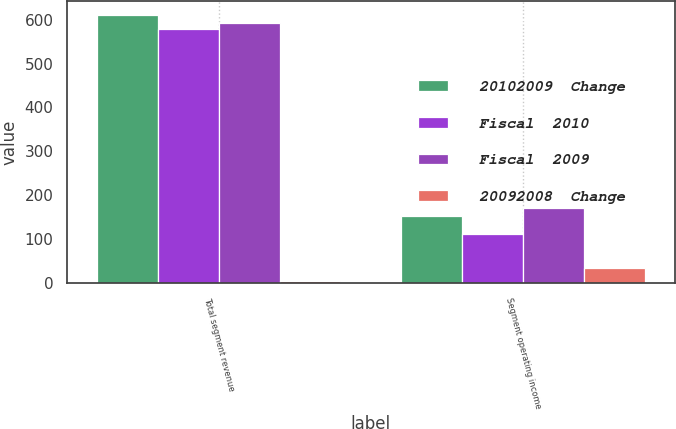<chart> <loc_0><loc_0><loc_500><loc_500><stacked_bar_chart><ecel><fcel>Total segment revenue<fcel>Segment operating income<nl><fcel>20102009  Change<fcel>611<fcel>152<nl><fcel>Fiscal  2010<fcel>579<fcel>113<nl><fcel>Fiscal  2009<fcel>592<fcel>170<nl><fcel>20092008  Change<fcel>6<fcel>34<nl></chart> 